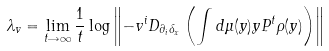Convert formula to latex. <formula><loc_0><loc_0><loc_500><loc_500>\lambda _ { v } = \lim _ { t \rightarrow \infty } \frac { 1 } { t } \log \left \| - v ^ { i } D _ { \partial _ { i } \delta _ { x } } \left ( \int d \mu ( y ) y P ^ { t } \rho ( y ) \right ) \right \|</formula> 